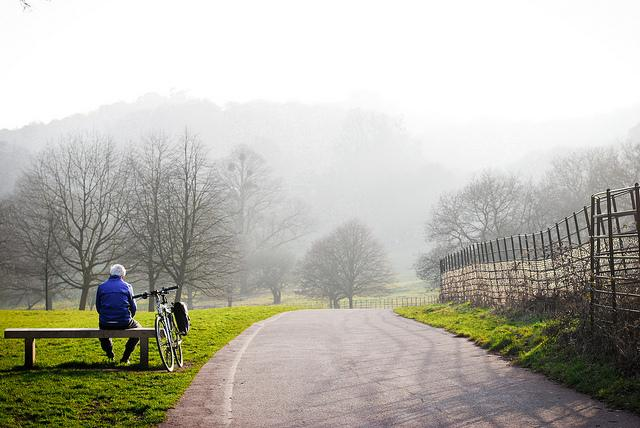Why is the sky so hazy?

Choices:
A) fog
B) fire
C) magic trick
D) factory smoke fog 